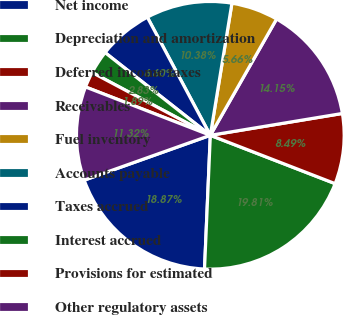Convert chart to OTSL. <chart><loc_0><loc_0><loc_500><loc_500><pie_chart><fcel>Net income<fcel>Depreciation and amortization<fcel>Deferred income taxes<fcel>Receivables<fcel>Fuel inventory<fcel>Accounts payable<fcel>Taxes accrued<fcel>Interest accrued<fcel>Provisions for estimated<fcel>Other regulatory assets<nl><fcel>18.87%<fcel>19.81%<fcel>8.49%<fcel>14.15%<fcel>5.66%<fcel>10.38%<fcel>6.6%<fcel>2.83%<fcel>1.89%<fcel>11.32%<nl></chart> 